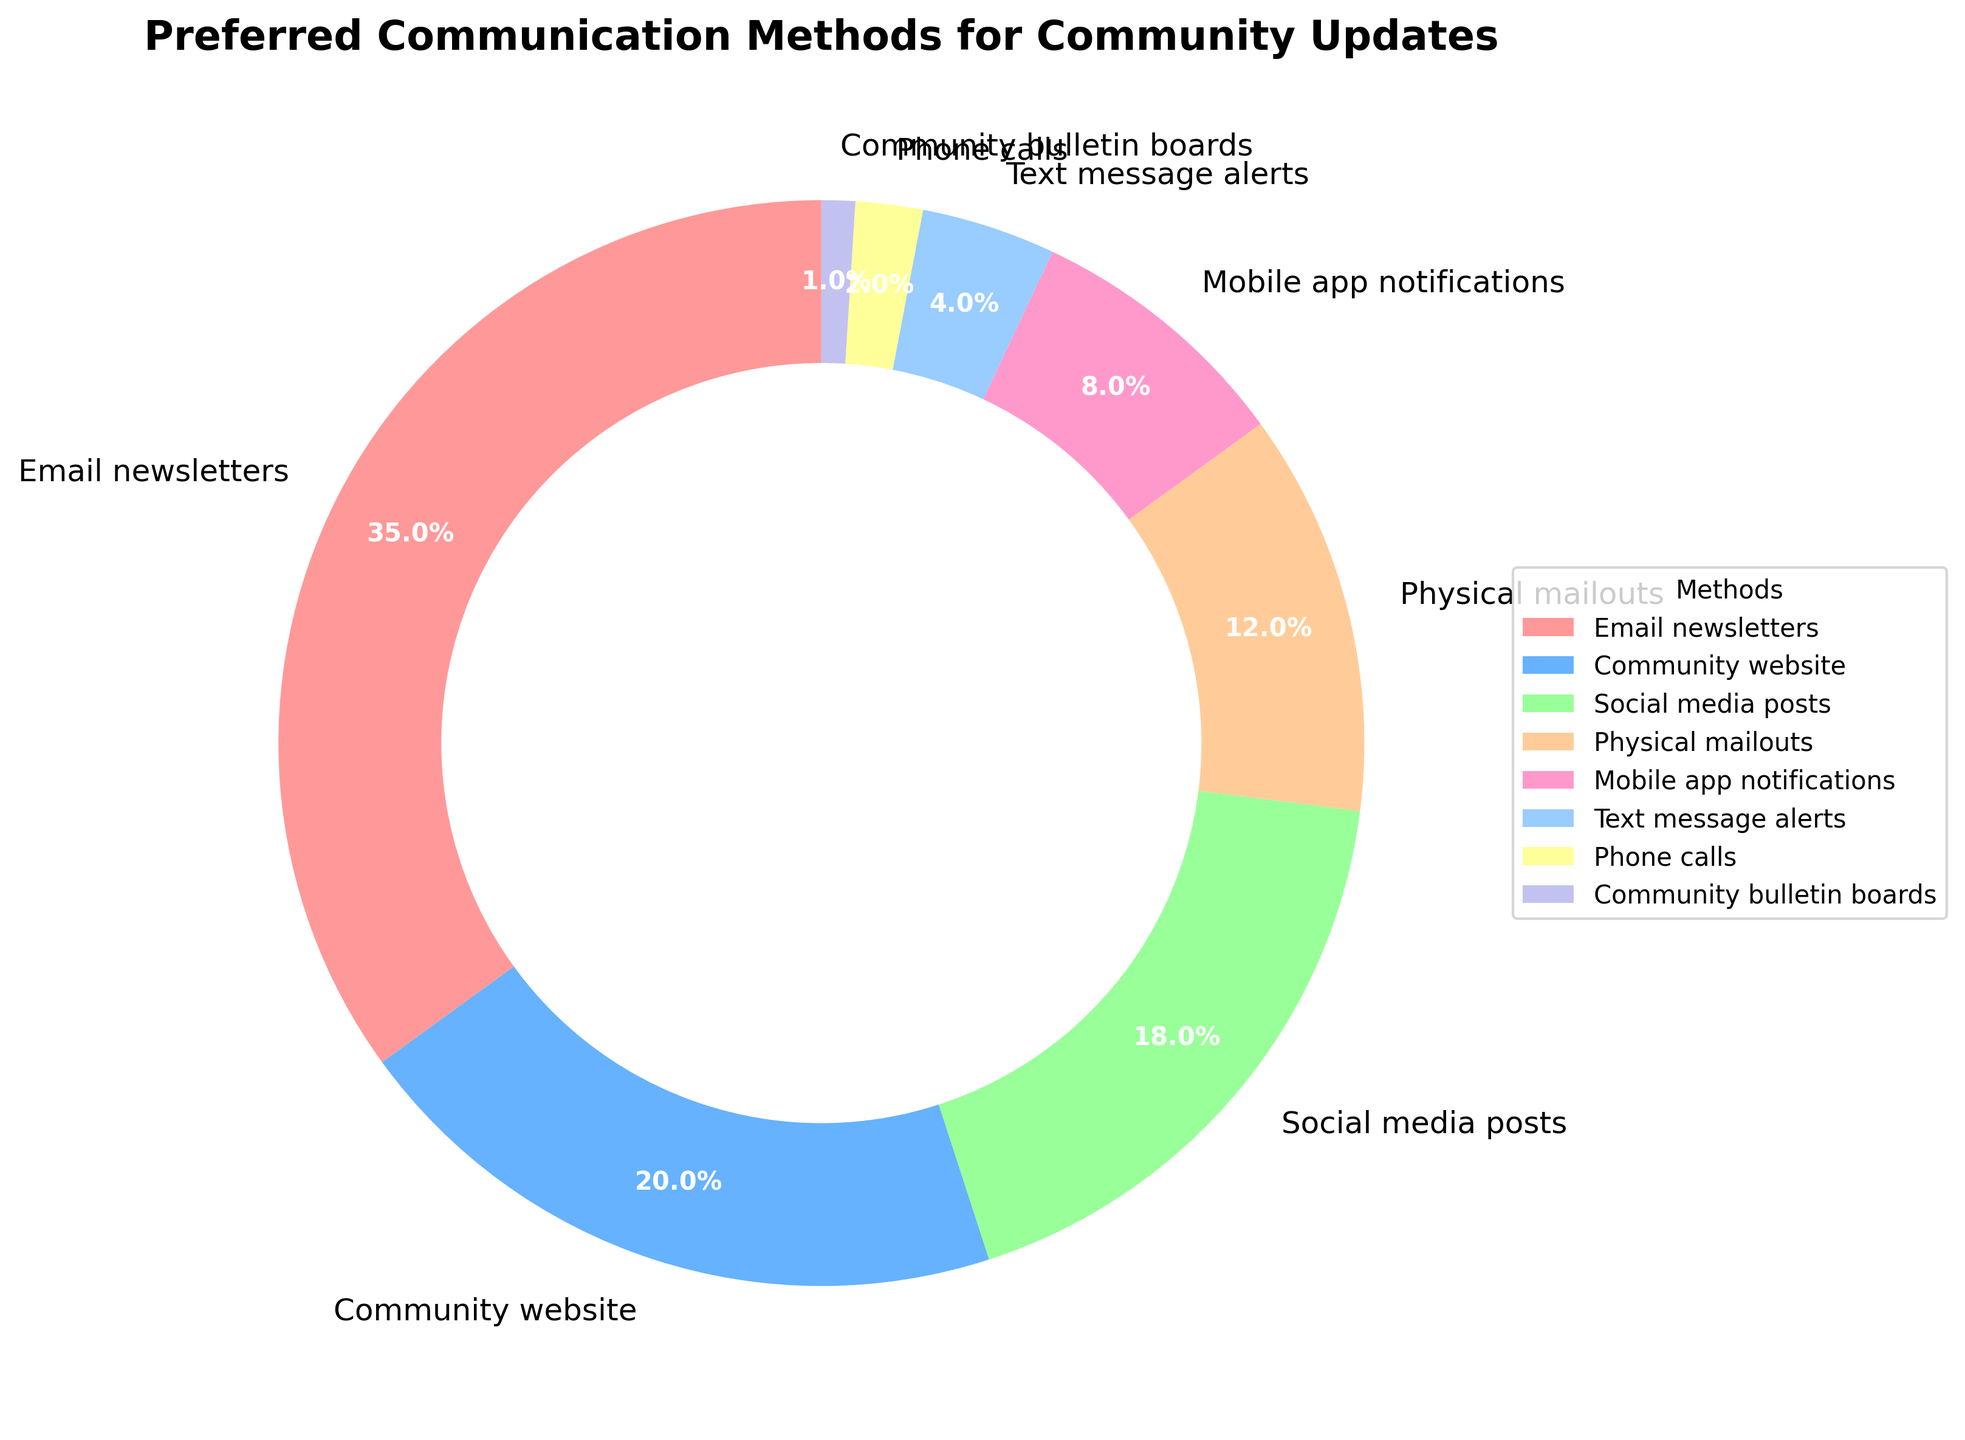What is the most preferred communication method for community updates? The figure shows a pie segment with the largest area labeled "Email newsletters" with a percentage of 35%. This is the highest among all the methods listed.
Answer: Email newsletters Which communication method is preferred by more people, social media posts or mobile app notifications? In the figure, "Social media posts" has a larger pie segment and is labeled with 18%, compared to "Mobile app notifications" which has a smaller segment labeled with 8%.
Answer: Social media posts What percentage of the community prefers text message alerts and phone calls combined for updates? The pie chart shows "Text message alerts" with 4% and "Phone calls" with 2%. Adding these percentages together gives 4% + 2% = 6%.
Answer: 6% How does the preference for physical mailouts compare to the preference for the community website? The pie chart shows "Physical mailouts" with 12% and "Community website" with 20%. Comparing these, 12% is less than 20%.
Answer: Less What is the difference in preference percentages between the most and least preferred communication methods? The highest preference (Email newsletters) is 35%, and the lowest (Community bulletin boards) is 1%. The difference is 35% - 1% = 34%.
Answer: 34% Which method has a preference closest to 10%? The pie segments closest to 10% are "Mobile app notifications" with 8% and "Physical mailouts" with 12%. The one closest to 10% is "Mobile app notifications".
Answer: Mobile app notifications How many communication methods are preferred by more than 15% of the community? The pie chart shows "Email newsletters" (35%), "Community website" (20%), and "Social media posts" (18%) exceeding 15%. There are three methods in total.
Answer: Three Rank the top three communication methods based on preference percentage. By examining the size and percentage labels of the pie chart segments, the top three methods are "Email newsletters" (35%), "Community website" (20%), and "Social media posts" (18%) in descending order.
Answer: Email newsletters, Community website, Social media posts What is the total percentage of community preference for digital communication methods (Email, Community website, Social media, Mobile app, and Text message)? Adding the percentages for "Email newsletters" (35%), "Community website" (20%), "Social media posts" (18%), "Mobile app notifications" (8%), and "Text message alerts" (4%) results in 35% + 20% + 18% + 8% + 4% = 85%.
Answer: 85% What is the combined percentage preference for non-digital methods (Physical mailouts, Phone calls, Community bulletin boards)? The pie chart shows "Physical mailouts" with 12%, "Phone calls" with 2%, and "Community bulletin boards" with 1%. The combined percentage is 12% + 2% + 1% = 15%.
Answer: 15% 